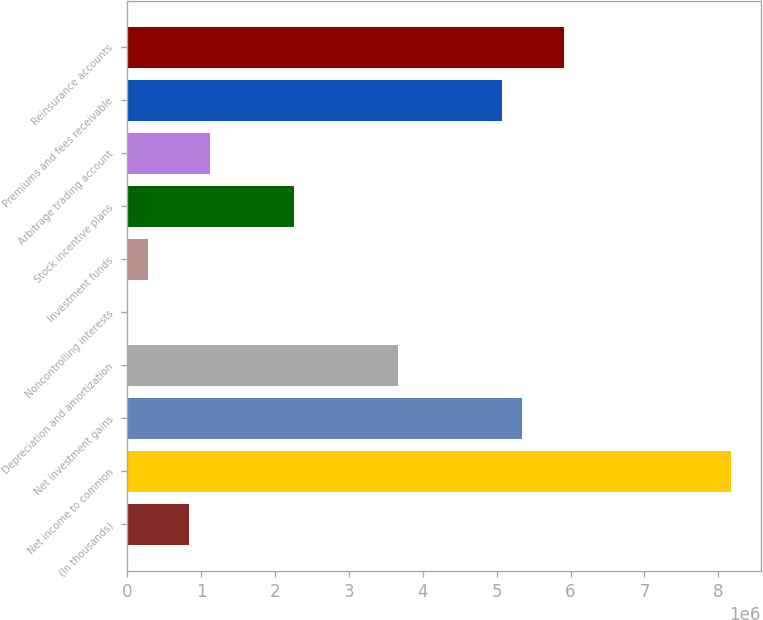Convert chart. <chart><loc_0><loc_0><loc_500><loc_500><bar_chart><fcel>(In thousands)<fcel>Net income to common<fcel>Net investment gains<fcel>Depreciation and amortization<fcel>Noncontrolling interests<fcel>Investment funds<fcel>Stock incentive plans<fcel>Arbitrage trading account<fcel>Premiums and fees receivable<fcel>Reinsurance accounts<nl><fcel>844651<fcel>8.16435e+06<fcel>5.34908e+06<fcel>3.65992e+06<fcel>70<fcel>281597<fcel>2.25229e+06<fcel>1.12618e+06<fcel>5.06756e+06<fcel>5.91214e+06<nl></chart> 